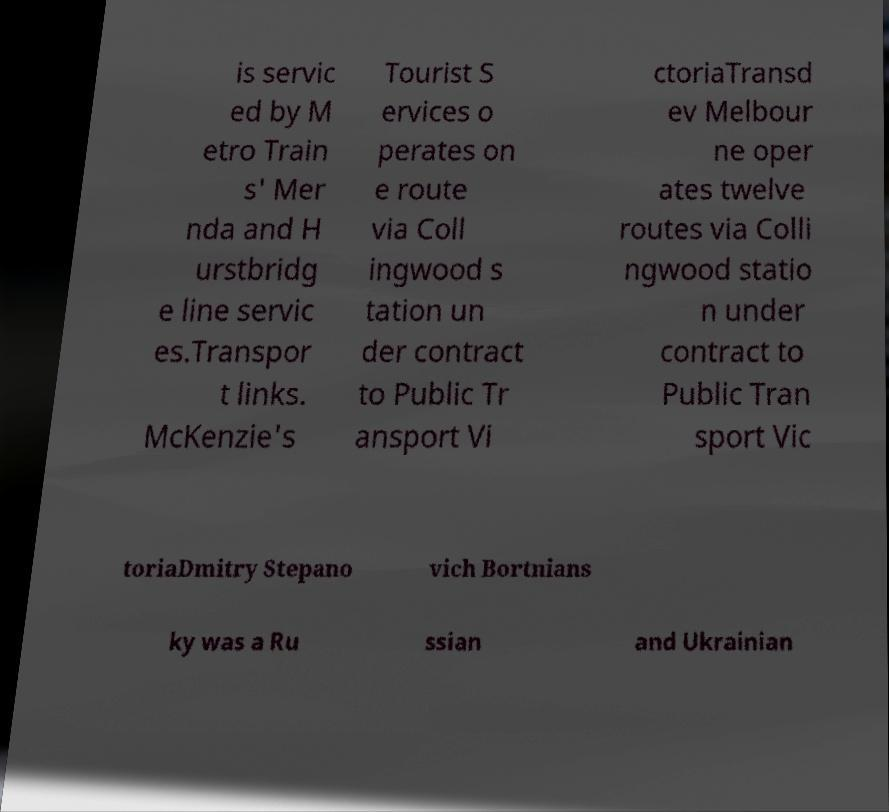Please read and relay the text visible in this image. What does it say? is servic ed by M etro Train s' Mer nda and H urstbridg e line servic es.Transpor t links. McKenzie's Tourist S ervices o perates on e route via Coll ingwood s tation un der contract to Public Tr ansport Vi ctoriaTransd ev Melbour ne oper ates twelve routes via Colli ngwood statio n under contract to Public Tran sport Vic toriaDmitry Stepano vich Bortnians ky was a Ru ssian and Ukrainian 